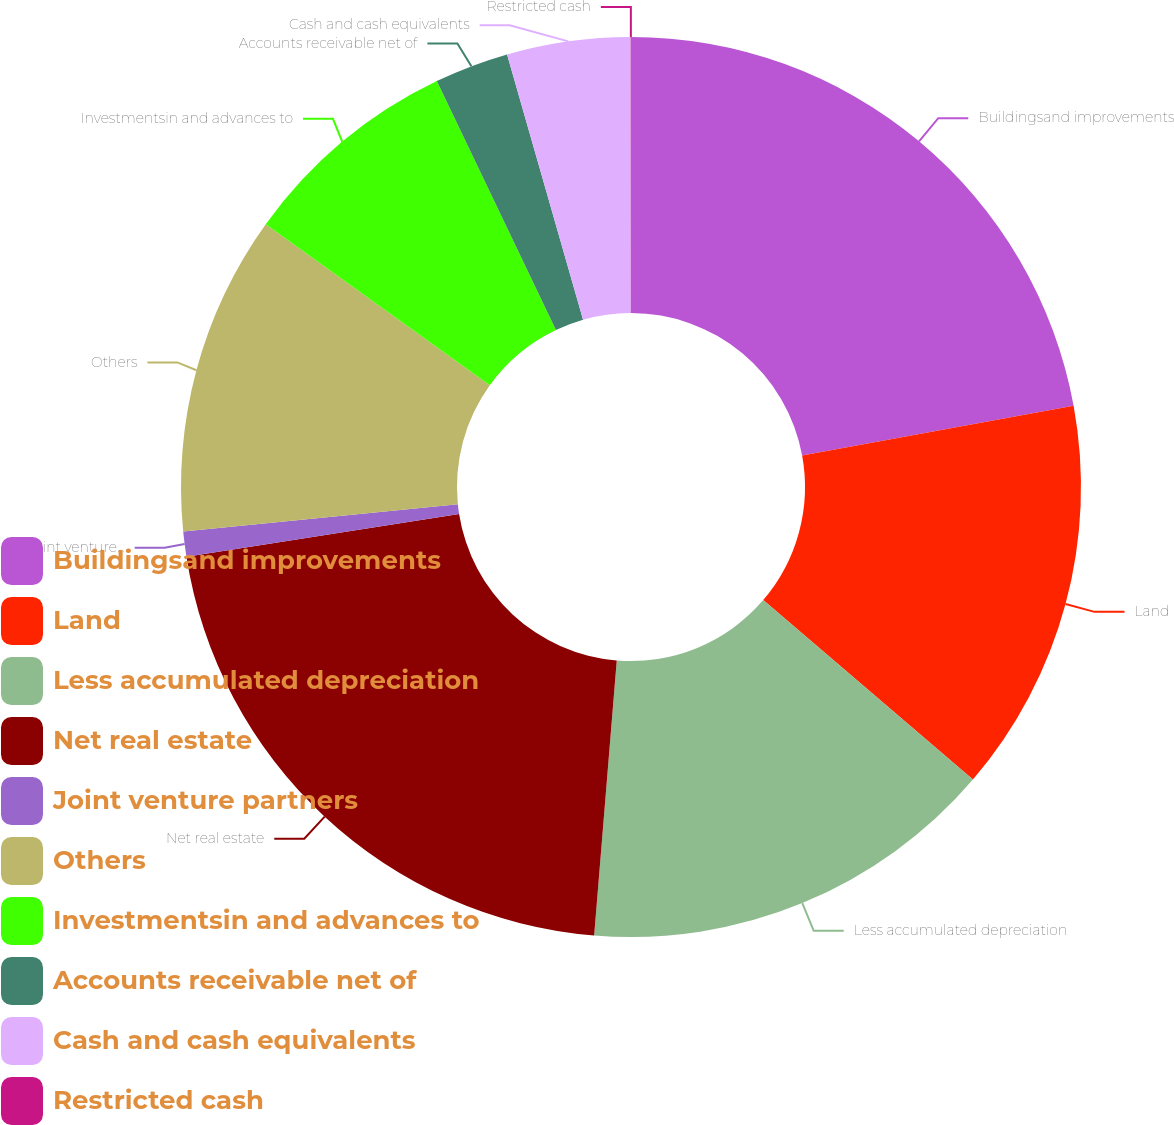<chart> <loc_0><loc_0><loc_500><loc_500><pie_chart><fcel>Buildingsand improvements<fcel>Land<fcel>Less accumulated depreciation<fcel>Net real estate<fcel>Joint venture partners<fcel>Others<fcel>Investmentsin and advances to<fcel>Accounts receivable net of<fcel>Cash and cash equivalents<fcel>Restricted cash<nl><fcel>22.11%<fcel>14.15%<fcel>15.04%<fcel>21.22%<fcel>0.9%<fcel>11.5%<fcel>7.97%<fcel>2.66%<fcel>4.43%<fcel>0.01%<nl></chart> 